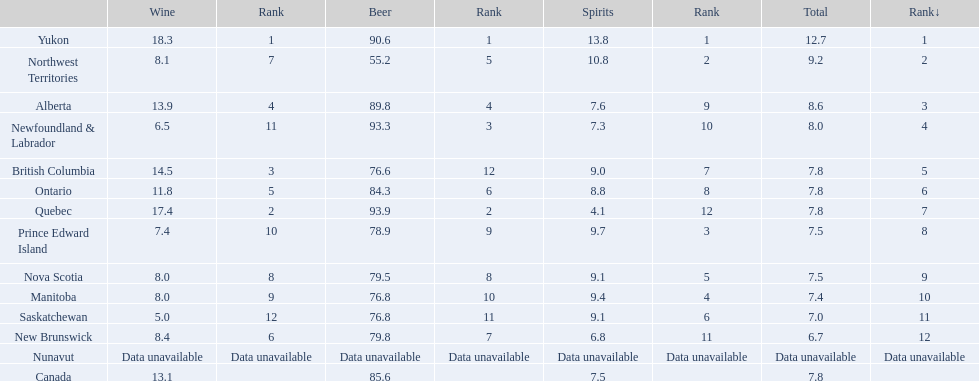In which places is the total consumption of alcoholic drinks equal to that of another place? British Columbia, Ontario, Quebec, Prince Edward Island, Nova Scotia. Among these, which ones have a beer consumption of more than 80? Ontario, Quebec. From this group, what was the spirit consumption of the place with the highest beer consumption? 4.1. 